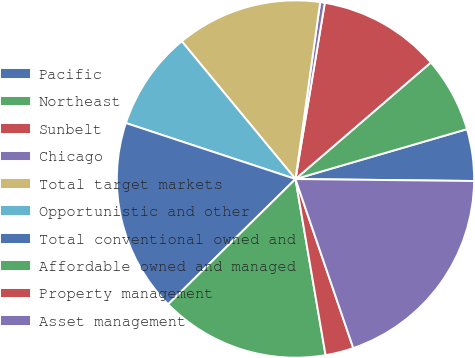Convert chart to OTSL. <chart><loc_0><loc_0><loc_500><loc_500><pie_chart><fcel>Pacific<fcel>Northeast<fcel>Sunbelt<fcel>Chicago<fcel>Total target markets<fcel>Opportunistic and other<fcel>Total conventional owned and<fcel>Affordable owned and managed<fcel>Property management<fcel>Asset management<nl><fcel>4.68%<fcel>6.81%<fcel>11.06%<fcel>0.42%<fcel>13.19%<fcel>8.94%<fcel>17.45%<fcel>15.32%<fcel>2.55%<fcel>19.58%<nl></chart> 